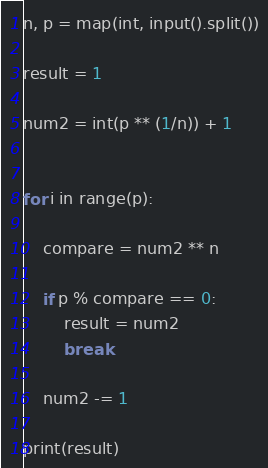<code> <loc_0><loc_0><loc_500><loc_500><_Python_>
n, p = map(int, input().split())

result = 1

num2 = int(p ** (1/n)) + 1


for i in range(p):

    compare = num2 ** n

    if p % compare == 0:
        result = num2
        break

    num2 -= 1

print(result)

</code> 